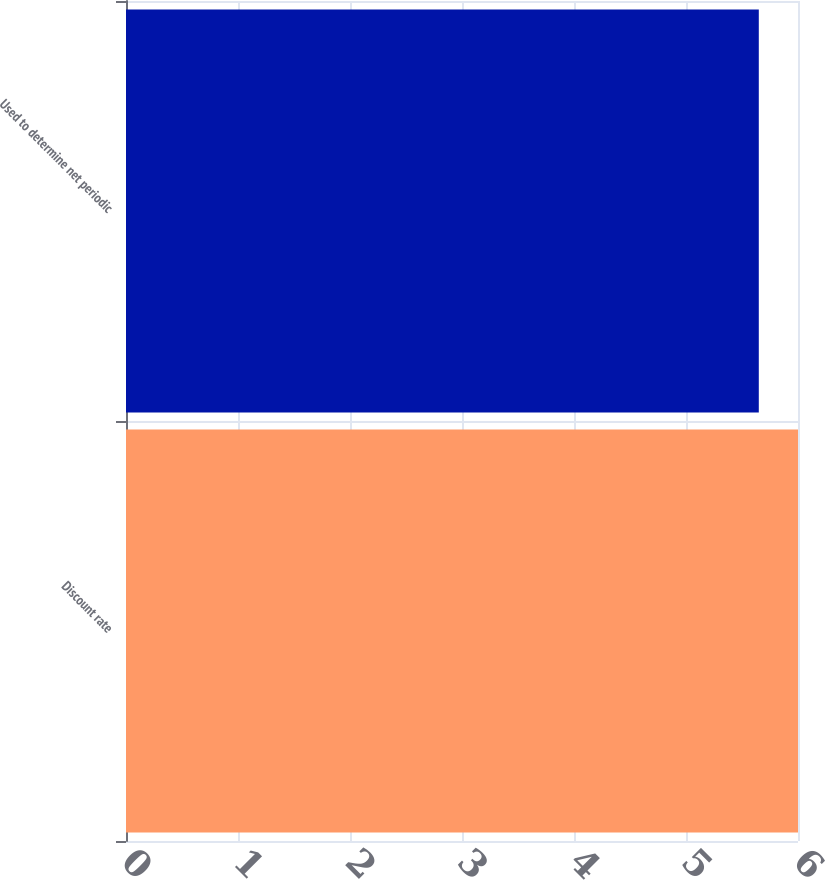<chart> <loc_0><loc_0><loc_500><loc_500><bar_chart><fcel>Discount rate<fcel>Used to determine net periodic<nl><fcel>6<fcel>5.65<nl></chart> 